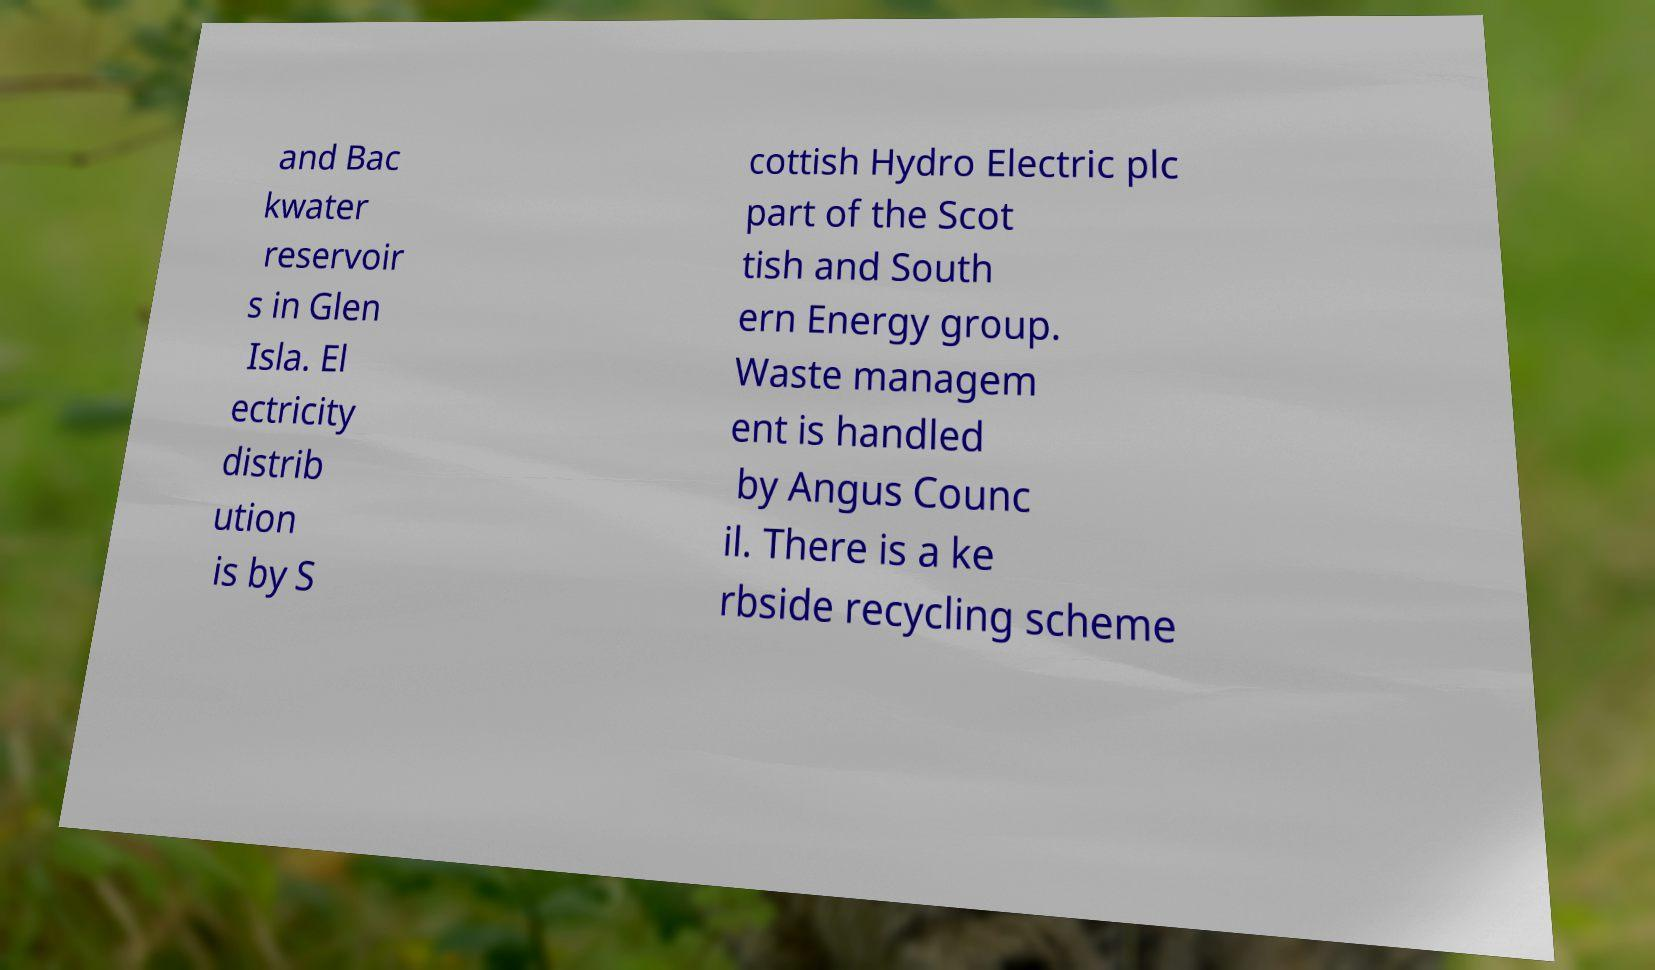There's text embedded in this image that I need extracted. Can you transcribe it verbatim? and Bac kwater reservoir s in Glen Isla. El ectricity distrib ution is by S cottish Hydro Electric plc part of the Scot tish and South ern Energy group. Waste managem ent is handled by Angus Counc il. There is a ke rbside recycling scheme 